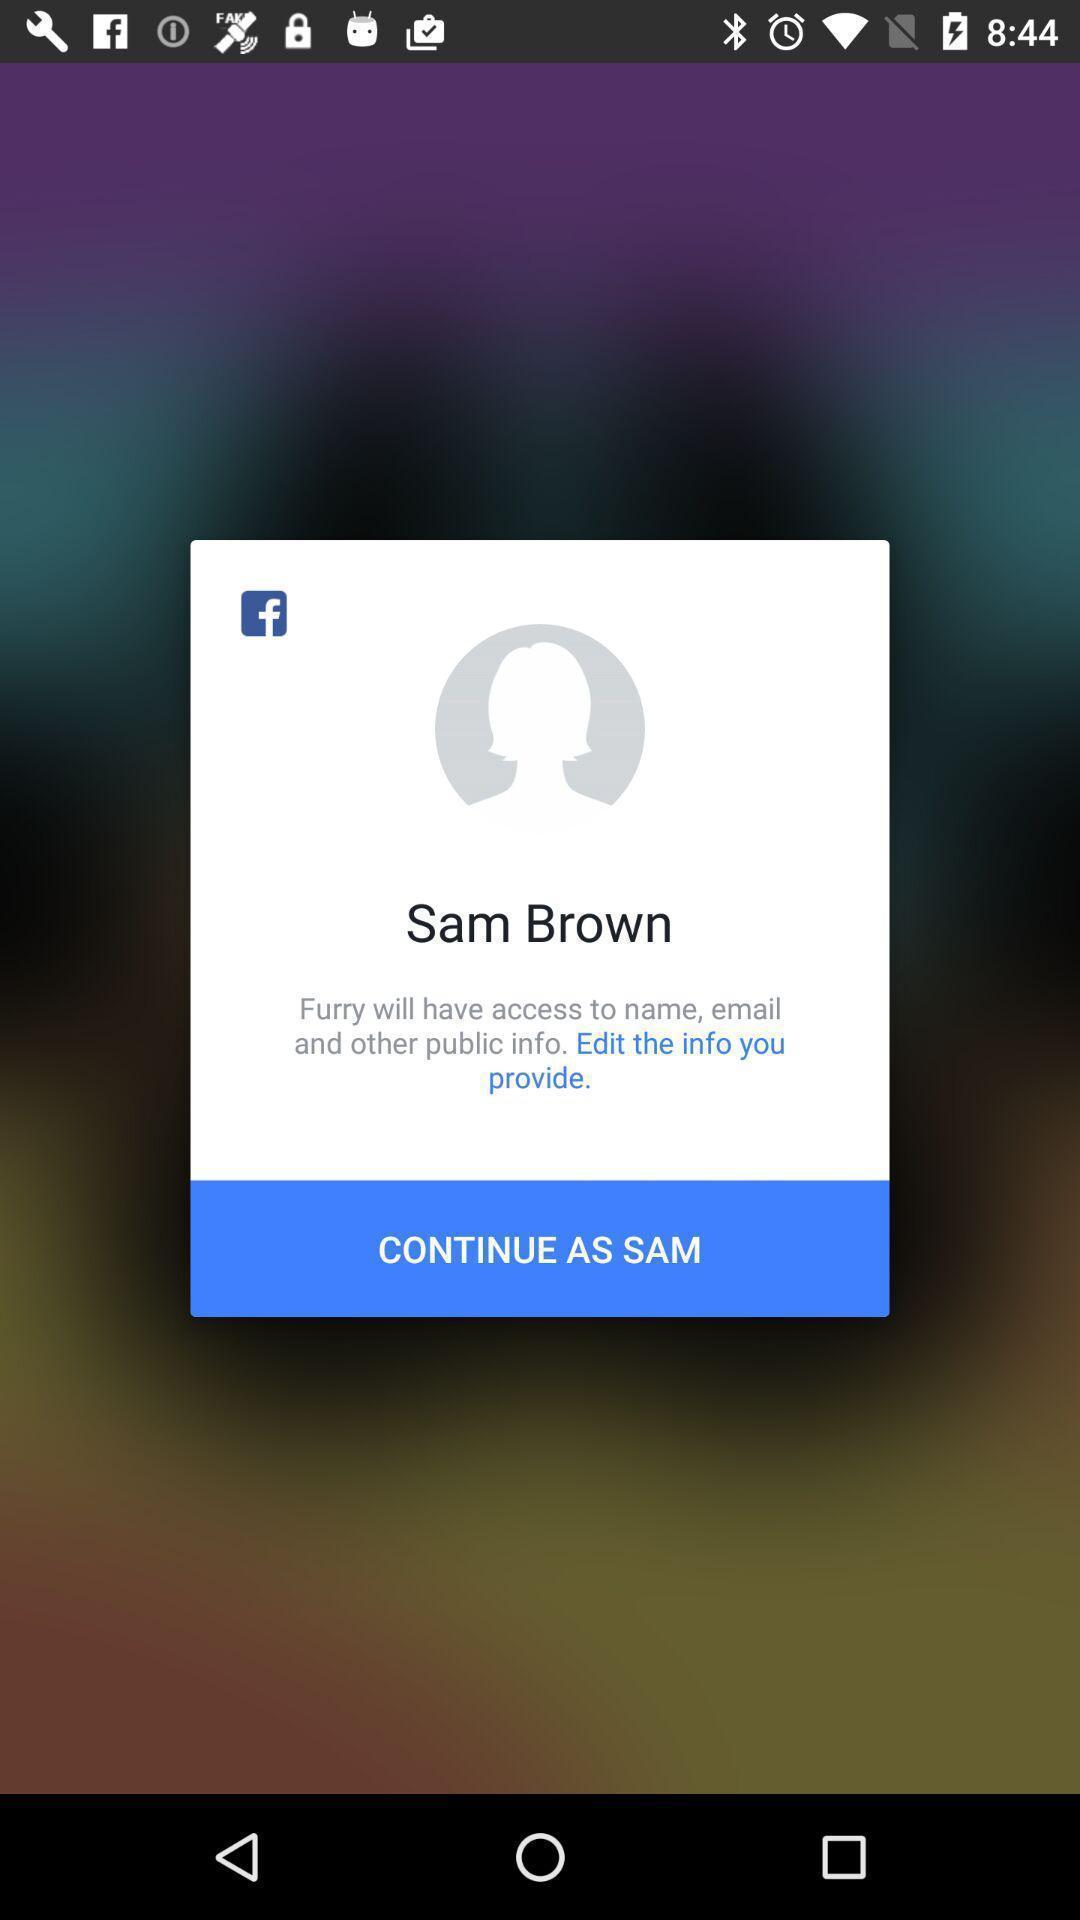Summarize the main components in this picture. Push up message for confirmation of social application. 